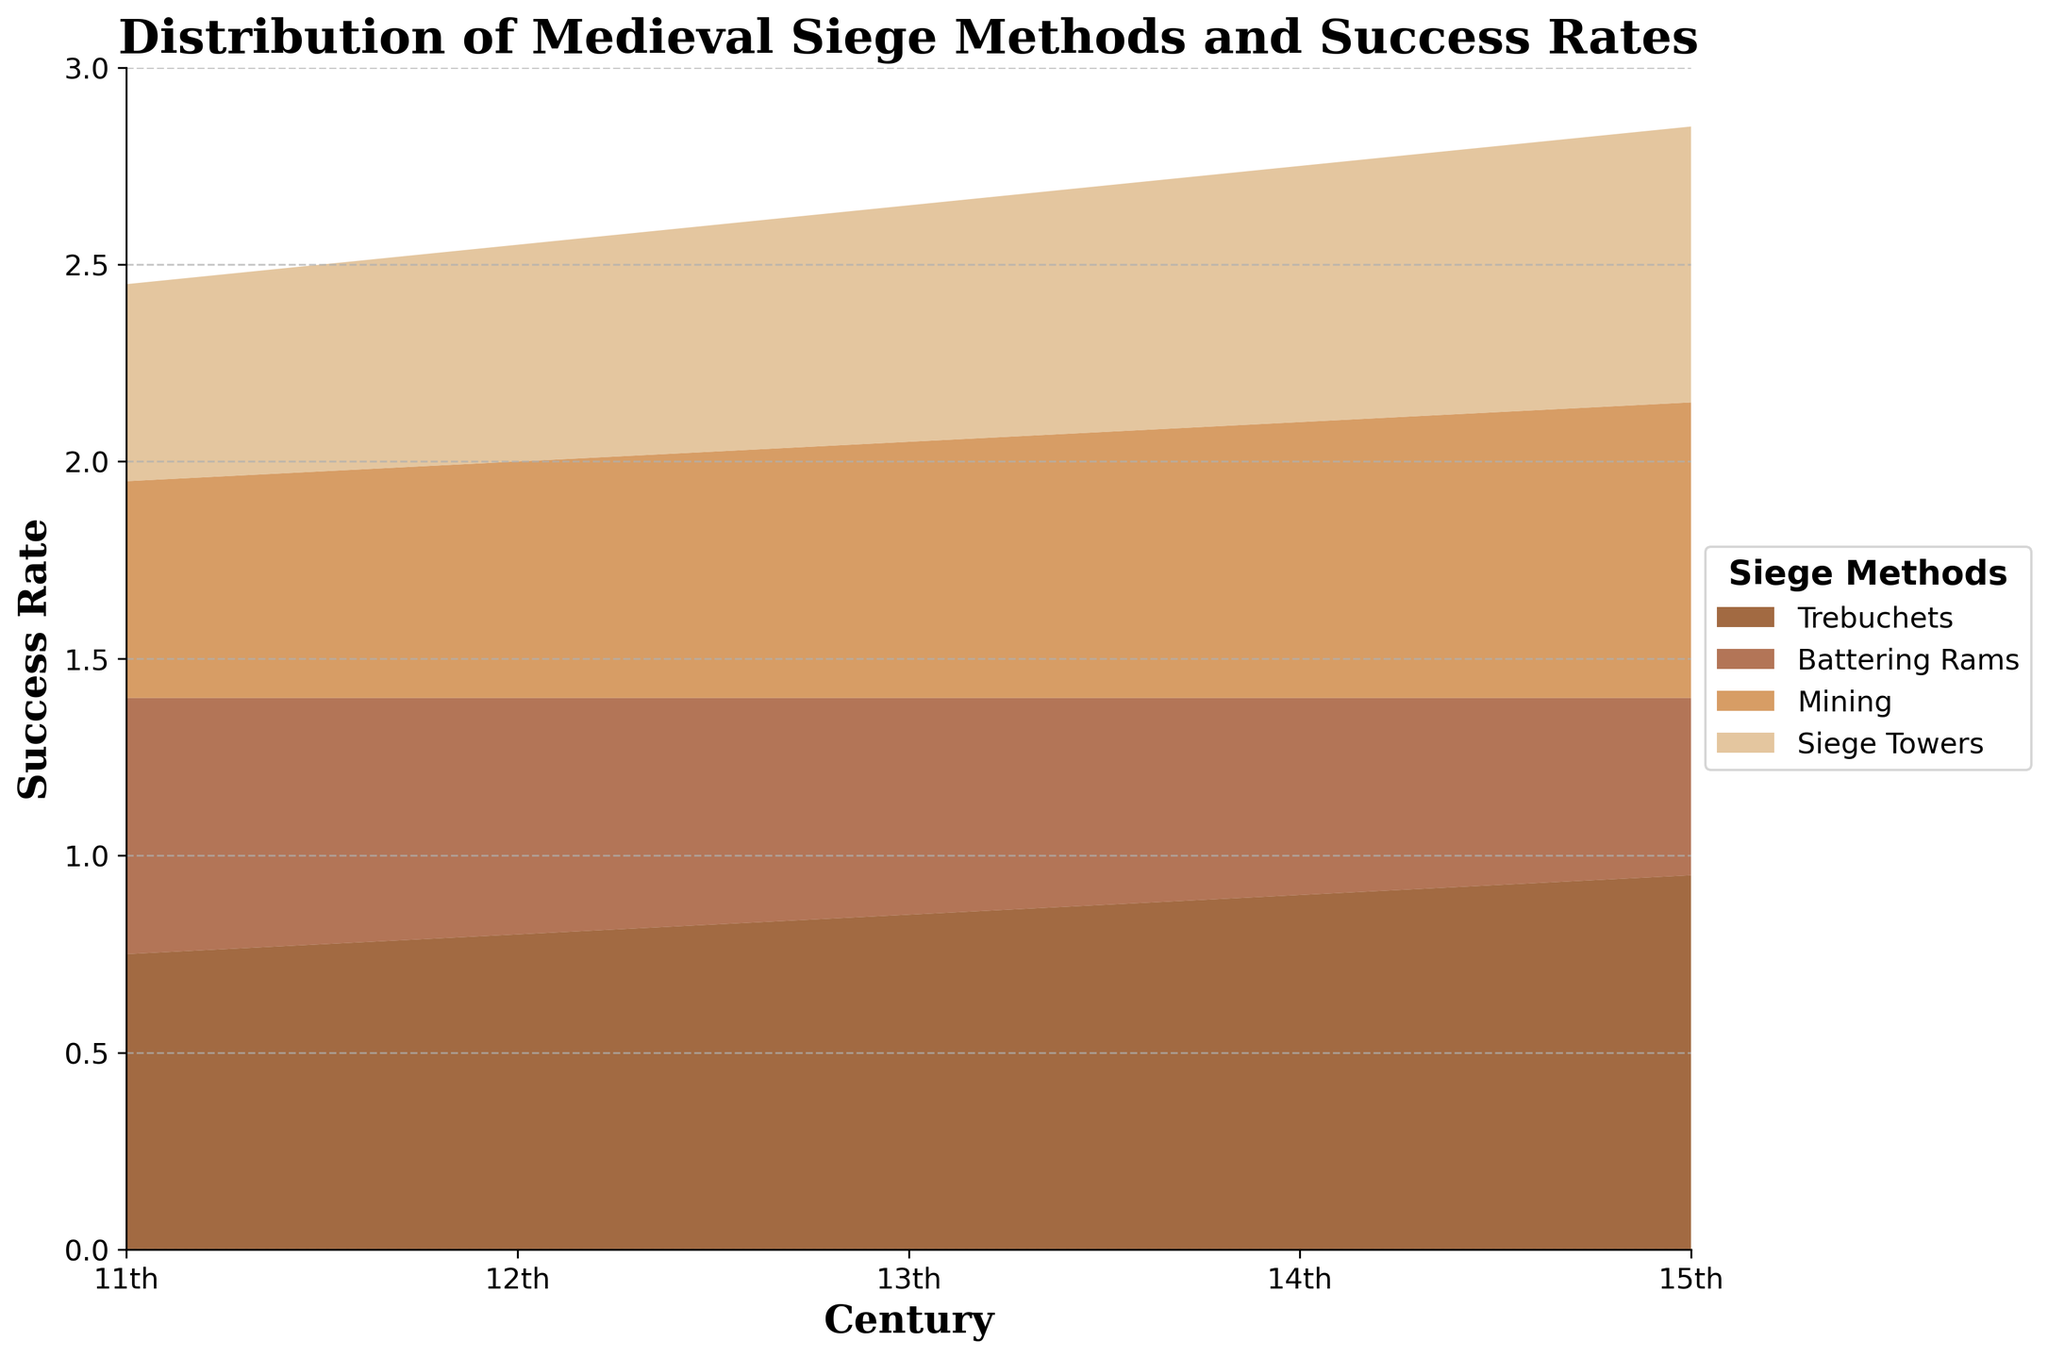What is the title of the figure? The title is located at the top of the figure in a larger font size. By reading it, we can determine the specific topic the figure addresses.
Answer: Distribution of Medieval Siege Methods and Success Rates What is the success rate of trebuchets in the 14th century? By locating the 14th century on the x-axis and finding the corresponding value for trebuchets, we see the exact success rate.
Answer: 0.90 Which siege method reached its peak success rate in the 15th century? By examining the curves in the 15th century, we see which method's success rate is the highest compared to other centuries.
Answer: Trebuchets Which century saw the lowest success rate for battering rams? Look across the centuries at the success rate of battering rams. The lowest point indicates the century with the lowest success rate.
Answer: 15th century Between the 12th and 13th centuries, which siege method had the largest improvement in success rate? Compare the success rate changes of each siege method between the 12th and 13th centuries to identify the largest increase.
Answer: Trebuchets What is the average success rate of mining in the 12th and 13th centuries? Add the success rates of mining for the 12th and 13th centuries, then divide by 2 to get the average.
Answer: (0.60 + 0.65) / 2 = 0.625 How does the success rate of siege towers in the 15th century compare to its success rate in the 11th century? Subtract the success rate of siege towers in the 11th century from that in the 15th century to find the difference.
Answer: 0.70 - 0.50 = 0.20 Which siege method showed the most consistent improvement in success rate across the centuries? Analyze the trend of success rates for each siege method across all the centuries to see which one continuously increased.
Answer: Trebuchets What is the combined success rate of all siege methods in the 13th century? Sum the success rates of all siege methods in the 13th century.
Answer: 0.85 + 0.55 + 0.65 + 0.60 = 2.65 Which siege method had the highest success rate in the 12th century, and what was it? Identify the highest point in the 12th century on the y-axis for each method to find the highest success rate.
Answer: Trebuchets, 0.80 